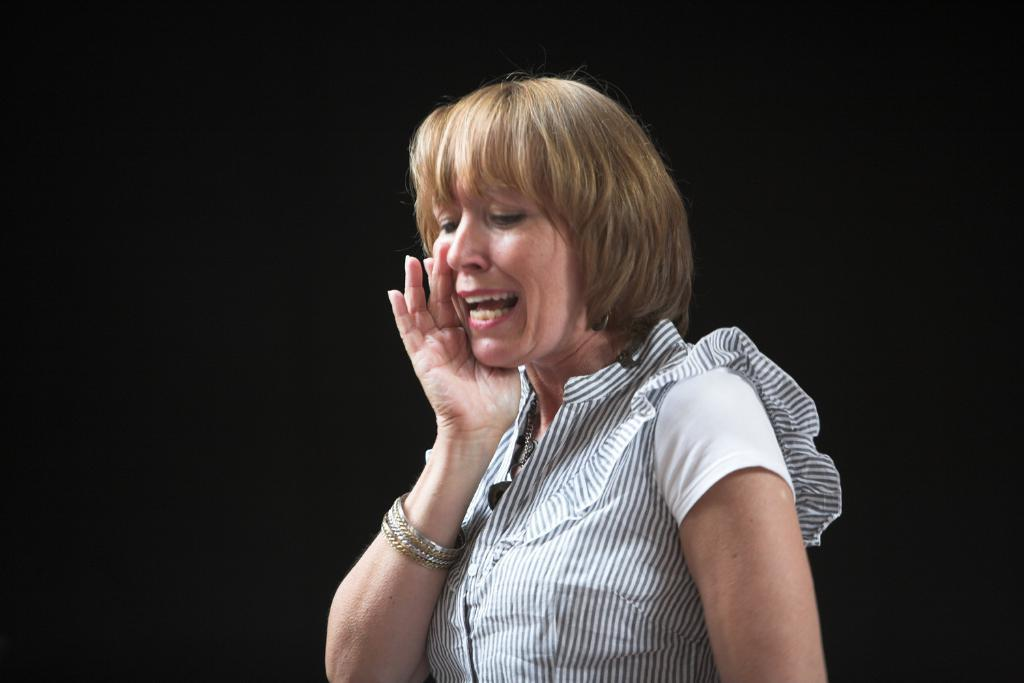Who is present in the image? There is a woman in the image. What is the woman doing in the image? The woman is doing something, but we cannot determine the specific action from the provided facts. What can be observed about the background of the image? The background of the image is dark. What type of honey can be seen dripping from the jellyfish in the image? There is no jellyfish or honey present in the image. 